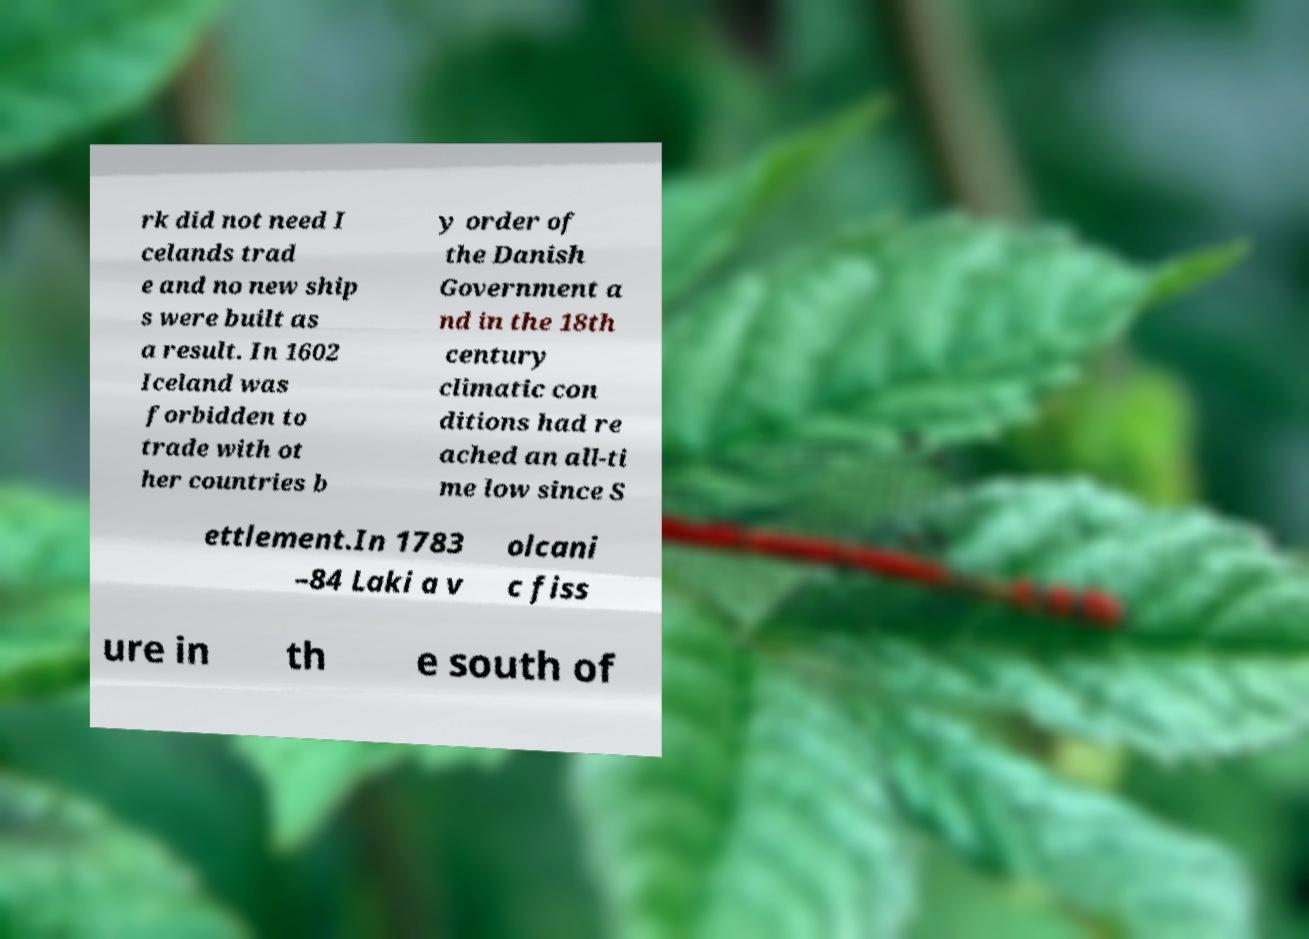Can you accurately transcribe the text from the provided image for me? rk did not need I celands trad e and no new ship s were built as a result. In 1602 Iceland was forbidden to trade with ot her countries b y order of the Danish Government a nd in the 18th century climatic con ditions had re ached an all-ti me low since S ettlement.In 1783 –84 Laki a v olcani c fiss ure in th e south of 